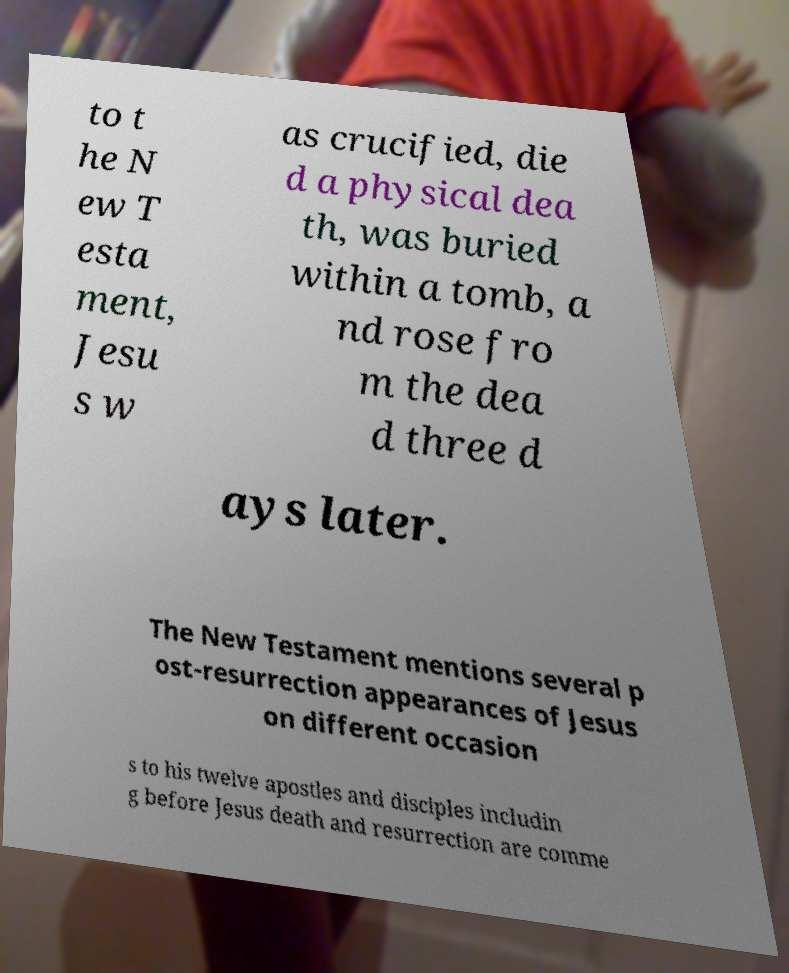I need the written content from this picture converted into text. Can you do that? to t he N ew T esta ment, Jesu s w as crucified, die d a physical dea th, was buried within a tomb, a nd rose fro m the dea d three d ays later. The New Testament mentions several p ost-resurrection appearances of Jesus on different occasion s to his twelve apostles and disciples includin g before Jesus death and resurrection are comme 